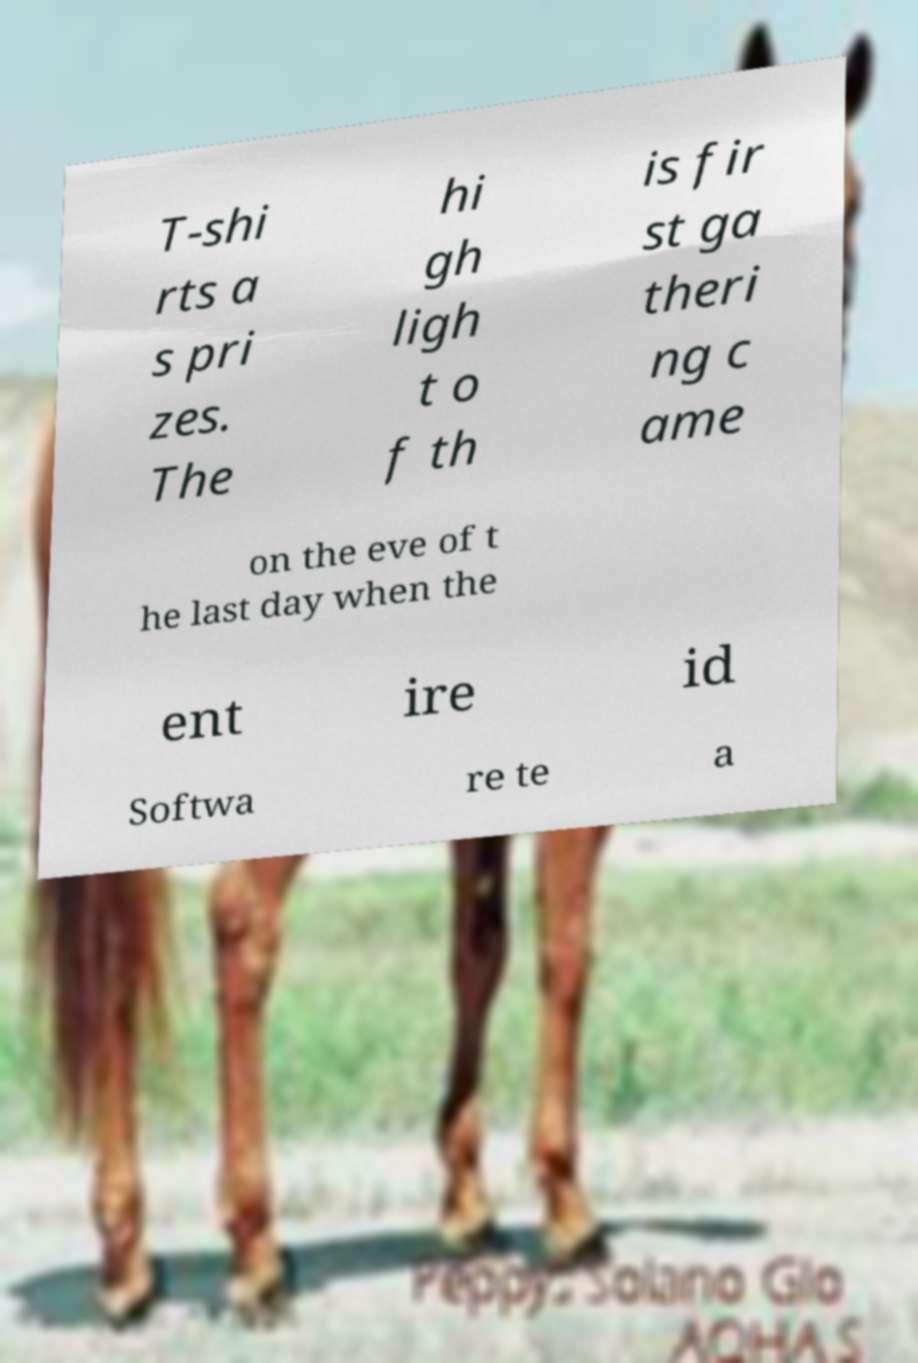Can you read and provide the text displayed in the image?This photo seems to have some interesting text. Can you extract and type it out for me? T-shi rts a s pri zes. The hi gh ligh t o f th is fir st ga theri ng c ame on the eve of t he last day when the ent ire id Softwa re te a 